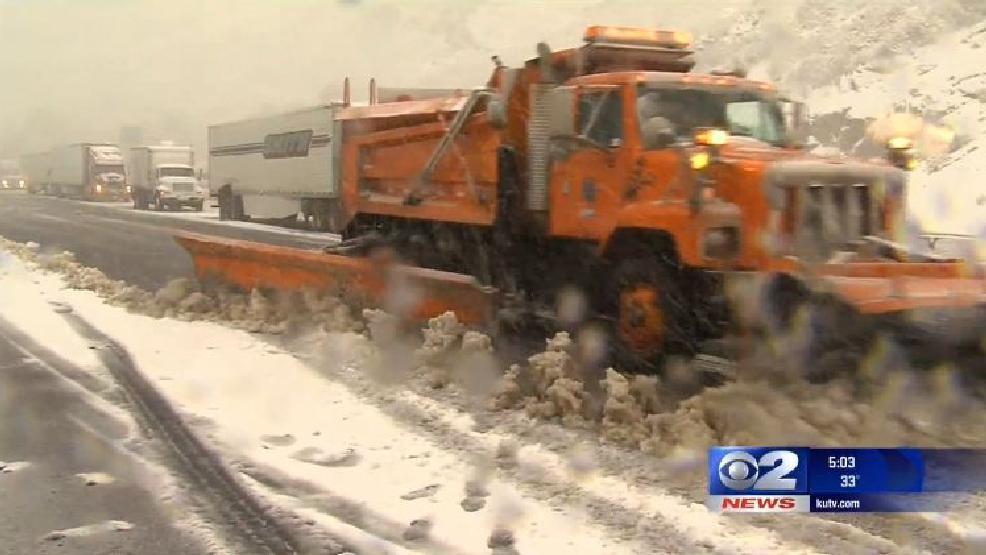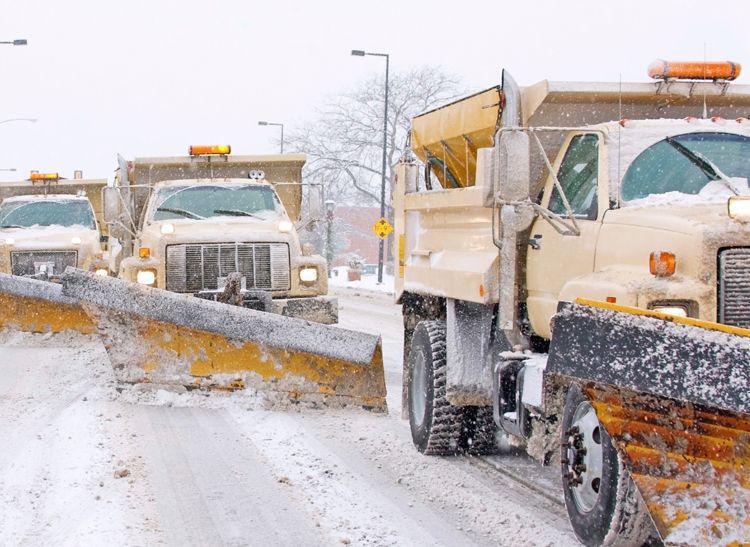The first image is the image on the left, the second image is the image on the right. Examine the images to the left and right. Is the description "The road in the image on the left is cleared of snow, while the snow is still being cleared in the image on the right." accurate? Answer yes or no. No. The first image is the image on the left, the second image is the image on the right. Given the left and right images, does the statement "Exactly one snow plow is plowing snow." hold true? Answer yes or no. No. 